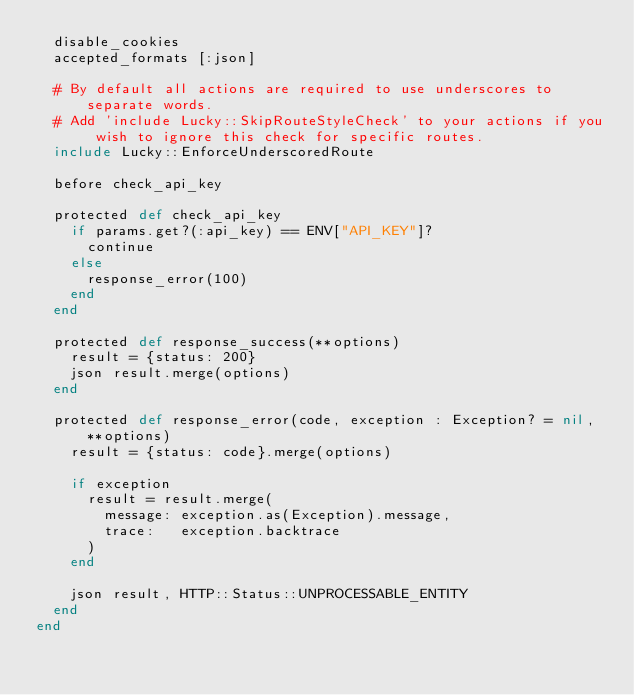<code> <loc_0><loc_0><loc_500><loc_500><_Crystal_>  disable_cookies
  accepted_formats [:json]

  # By default all actions are required to use underscores to separate words.
  # Add 'include Lucky::SkipRouteStyleCheck' to your actions if you wish to ignore this check for specific routes.
  include Lucky::EnforceUnderscoredRoute

  before check_api_key

  protected def check_api_key
    if params.get?(:api_key) == ENV["API_KEY"]?
      continue
    else
      response_error(100)
    end
  end

  protected def response_success(**options)
    result = {status: 200}
    json result.merge(options)
  end

  protected def response_error(code, exception : Exception? = nil, **options)
    result = {status: code}.merge(options)

    if exception
      result = result.merge(
        message: exception.as(Exception).message,
        trace:   exception.backtrace
      )
    end

    json result, HTTP::Status::UNPROCESSABLE_ENTITY
  end
end
</code> 